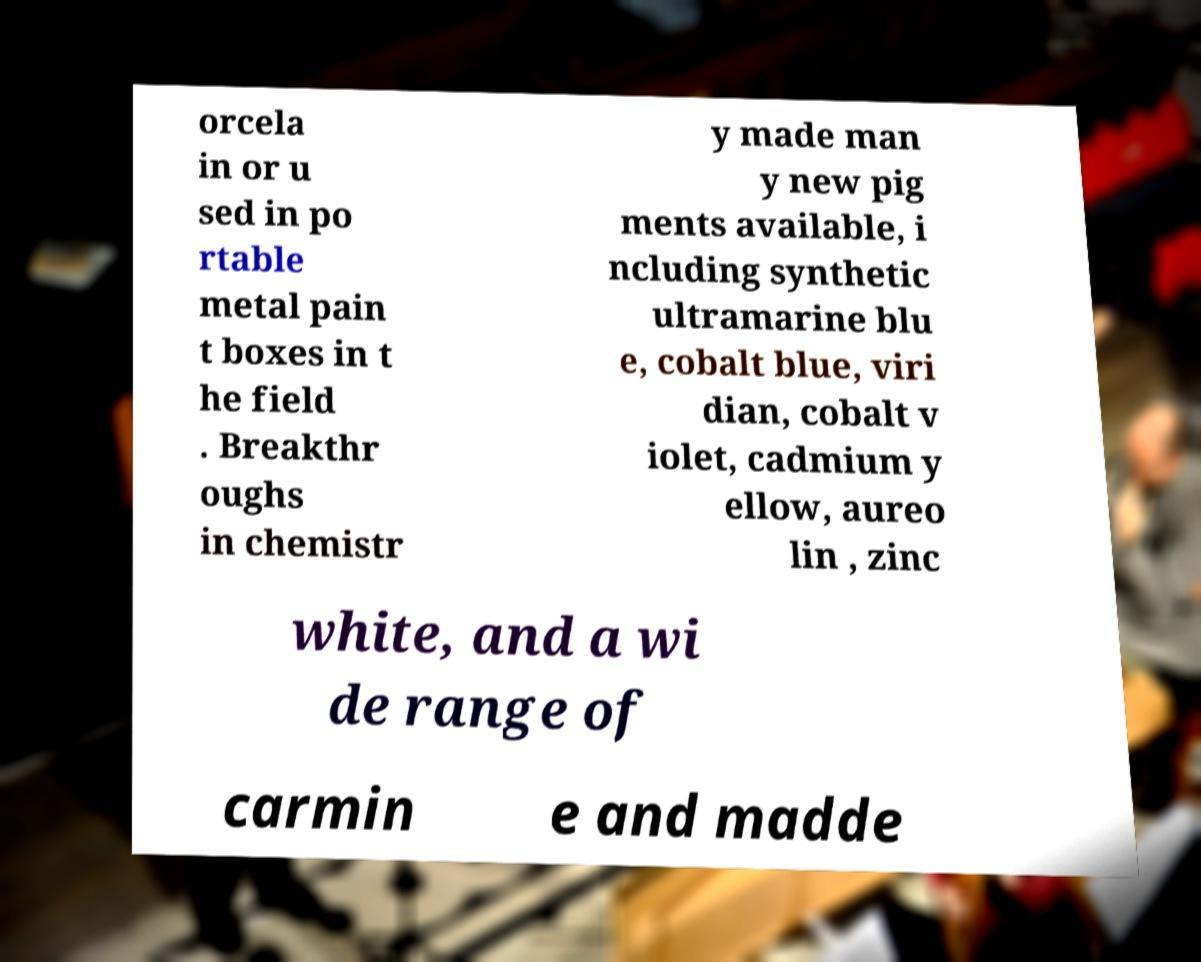For documentation purposes, I need the text within this image transcribed. Could you provide that? orcela in or u sed in po rtable metal pain t boxes in t he field . Breakthr oughs in chemistr y made man y new pig ments available, i ncluding synthetic ultramarine blu e, cobalt blue, viri dian, cobalt v iolet, cadmium y ellow, aureo lin , zinc white, and a wi de range of carmin e and madde 